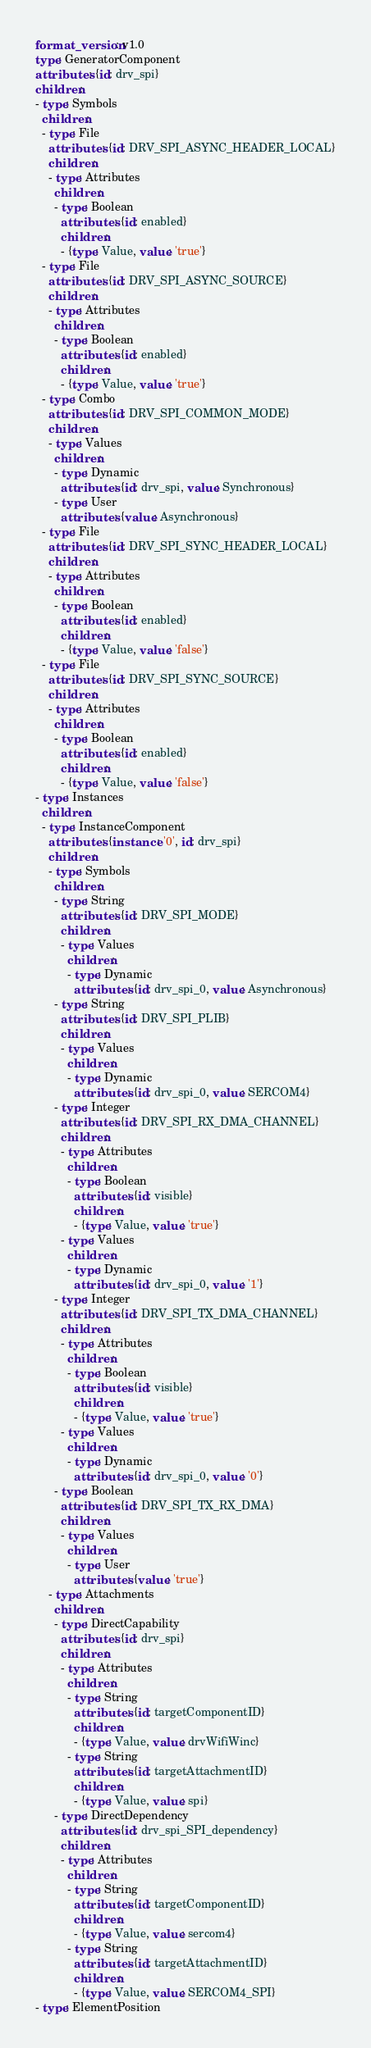<code> <loc_0><loc_0><loc_500><loc_500><_YAML_>format_version: v1.0
type: GeneratorComponent
attributes: {id: drv_spi}
children:
- type: Symbols
  children:
  - type: File
    attributes: {id: DRV_SPI_ASYNC_HEADER_LOCAL}
    children:
    - type: Attributes
      children:
      - type: Boolean
        attributes: {id: enabled}
        children:
        - {type: Value, value: 'true'}
  - type: File
    attributes: {id: DRV_SPI_ASYNC_SOURCE}
    children:
    - type: Attributes
      children:
      - type: Boolean
        attributes: {id: enabled}
        children:
        - {type: Value, value: 'true'}
  - type: Combo
    attributes: {id: DRV_SPI_COMMON_MODE}
    children:
    - type: Values
      children:
      - type: Dynamic
        attributes: {id: drv_spi, value: Synchronous}
      - type: User
        attributes: {value: Asynchronous}
  - type: File
    attributes: {id: DRV_SPI_SYNC_HEADER_LOCAL}
    children:
    - type: Attributes
      children:
      - type: Boolean
        attributes: {id: enabled}
        children:
        - {type: Value, value: 'false'}
  - type: File
    attributes: {id: DRV_SPI_SYNC_SOURCE}
    children:
    - type: Attributes
      children:
      - type: Boolean
        attributes: {id: enabled}
        children:
        - {type: Value, value: 'false'}
- type: Instances
  children:
  - type: InstanceComponent
    attributes: {instance: '0', id: drv_spi}
    children:
    - type: Symbols
      children:
      - type: String
        attributes: {id: DRV_SPI_MODE}
        children:
        - type: Values
          children:
          - type: Dynamic
            attributes: {id: drv_spi_0, value: Asynchronous}
      - type: String
        attributes: {id: DRV_SPI_PLIB}
        children:
        - type: Values
          children:
          - type: Dynamic
            attributes: {id: drv_spi_0, value: SERCOM4}
      - type: Integer
        attributes: {id: DRV_SPI_RX_DMA_CHANNEL}
        children:
        - type: Attributes
          children:
          - type: Boolean
            attributes: {id: visible}
            children:
            - {type: Value, value: 'true'}
        - type: Values
          children:
          - type: Dynamic
            attributes: {id: drv_spi_0, value: '1'}
      - type: Integer
        attributes: {id: DRV_SPI_TX_DMA_CHANNEL}
        children:
        - type: Attributes
          children:
          - type: Boolean
            attributes: {id: visible}
            children:
            - {type: Value, value: 'true'}
        - type: Values
          children:
          - type: Dynamic
            attributes: {id: drv_spi_0, value: '0'}
      - type: Boolean
        attributes: {id: DRV_SPI_TX_RX_DMA}
        children:
        - type: Values
          children:
          - type: User
            attributes: {value: 'true'}
    - type: Attachments
      children:
      - type: DirectCapability
        attributes: {id: drv_spi}
        children:
        - type: Attributes
          children:
          - type: String
            attributes: {id: targetComponentID}
            children:
            - {type: Value, value: drvWifiWinc}
          - type: String
            attributes: {id: targetAttachmentID}
            children:
            - {type: Value, value: spi}
      - type: DirectDependency
        attributes: {id: drv_spi_SPI_dependency}
        children:
        - type: Attributes
          children:
          - type: String
            attributes: {id: targetComponentID}
            children:
            - {type: Value, value: sercom4}
          - type: String
            attributes: {id: targetAttachmentID}
            children:
            - {type: Value, value: SERCOM4_SPI}
- type: ElementPosition</code> 